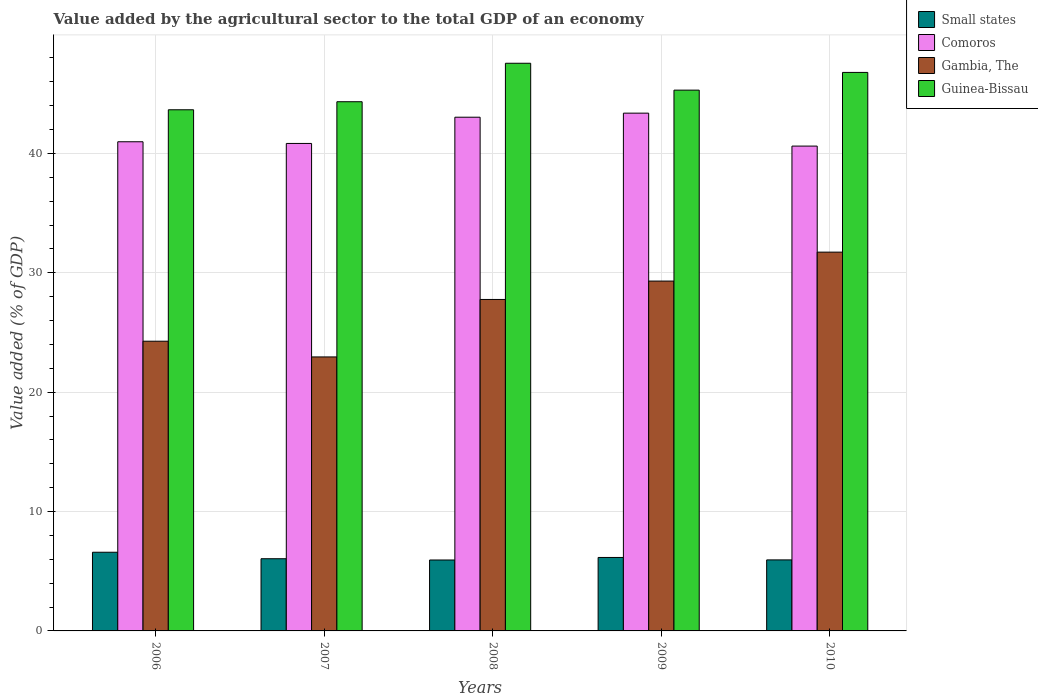How many different coloured bars are there?
Your answer should be compact. 4. How many groups of bars are there?
Give a very brief answer. 5. Are the number of bars per tick equal to the number of legend labels?
Ensure brevity in your answer.  Yes. Are the number of bars on each tick of the X-axis equal?
Provide a succinct answer. Yes. How many bars are there on the 4th tick from the right?
Provide a short and direct response. 4. In how many cases, is the number of bars for a given year not equal to the number of legend labels?
Provide a succinct answer. 0. What is the value added by the agricultural sector to the total GDP in Small states in 2008?
Your answer should be compact. 5.94. Across all years, what is the maximum value added by the agricultural sector to the total GDP in Guinea-Bissau?
Make the answer very short. 47.55. Across all years, what is the minimum value added by the agricultural sector to the total GDP in Comoros?
Your answer should be compact. 40.61. In which year was the value added by the agricultural sector to the total GDP in Small states minimum?
Your answer should be very brief. 2008. What is the total value added by the agricultural sector to the total GDP in Comoros in the graph?
Your answer should be very brief. 208.81. What is the difference between the value added by the agricultural sector to the total GDP in Gambia, The in 2007 and that in 2010?
Provide a short and direct response. -8.78. What is the difference between the value added by the agricultural sector to the total GDP in Small states in 2008 and the value added by the agricultural sector to the total GDP in Guinea-Bissau in 2006?
Ensure brevity in your answer.  -37.71. What is the average value added by the agricultural sector to the total GDP in Small states per year?
Provide a succinct answer. 6.14. In the year 2006, what is the difference between the value added by the agricultural sector to the total GDP in Guinea-Bissau and value added by the agricultural sector to the total GDP in Comoros?
Ensure brevity in your answer.  2.68. What is the ratio of the value added by the agricultural sector to the total GDP in Guinea-Bissau in 2007 to that in 2009?
Make the answer very short. 0.98. Is the value added by the agricultural sector to the total GDP in Guinea-Bissau in 2008 less than that in 2009?
Ensure brevity in your answer.  No. Is the difference between the value added by the agricultural sector to the total GDP in Guinea-Bissau in 2007 and 2008 greater than the difference between the value added by the agricultural sector to the total GDP in Comoros in 2007 and 2008?
Offer a terse response. No. What is the difference between the highest and the second highest value added by the agricultural sector to the total GDP in Small states?
Keep it short and to the point. 0.44. What is the difference between the highest and the lowest value added by the agricultural sector to the total GDP in Guinea-Bissau?
Offer a very short reply. 3.9. In how many years, is the value added by the agricultural sector to the total GDP in Guinea-Bissau greater than the average value added by the agricultural sector to the total GDP in Guinea-Bissau taken over all years?
Offer a terse response. 2. Is the sum of the value added by the agricultural sector to the total GDP in Guinea-Bissau in 2008 and 2010 greater than the maximum value added by the agricultural sector to the total GDP in Gambia, The across all years?
Give a very brief answer. Yes. Is it the case that in every year, the sum of the value added by the agricultural sector to the total GDP in Comoros and value added by the agricultural sector to the total GDP in Gambia, The is greater than the sum of value added by the agricultural sector to the total GDP in Guinea-Bissau and value added by the agricultural sector to the total GDP in Small states?
Give a very brief answer. No. What does the 3rd bar from the left in 2010 represents?
Give a very brief answer. Gambia, The. What does the 3rd bar from the right in 2009 represents?
Your answer should be compact. Comoros. How many years are there in the graph?
Make the answer very short. 5. What is the difference between two consecutive major ticks on the Y-axis?
Offer a very short reply. 10. Are the values on the major ticks of Y-axis written in scientific E-notation?
Ensure brevity in your answer.  No. Does the graph contain any zero values?
Your response must be concise. No. Does the graph contain grids?
Make the answer very short. Yes. What is the title of the graph?
Offer a terse response. Value added by the agricultural sector to the total GDP of an economy. Does "Middle East & North Africa (developing only)" appear as one of the legend labels in the graph?
Your response must be concise. No. What is the label or title of the X-axis?
Give a very brief answer. Years. What is the label or title of the Y-axis?
Ensure brevity in your answer.  Value added (% of GDP). What is the Value added (% of GDP) in Small states in 2006?
Your answer should be compact. 6.59. What is the Value added (% of GDP) of Comoros in 2006?
Your response must be concise. 40.97. What is the Value added (% of GDP) in Gambia, The in 2006?
Provide a short and direct response. 24.27. What is the Value added (% of GDP) of Guinea-Bissau in 2006?
Offer a very short reply. 43.65. What is the Value added (% of GDP) in Small states in 2007?
Provide a succinct answer. 6.05. What is the Value added (% of GDP) in Comoros in 2007?
Your answer should be very brief. 40.83. What is the Value added (% of GDP) in Gambia, The in 2007?
Keep it short and to the point. 22.95. What is the Value added (% of GDP) in Guinea-Bissau in 2007?
Give a very brief answer. 44.33. What is the Value added (% of GDP) of Small states in 2008?
Give a very brief answer. 5.94. What is the Value added (% of GDP) in Comoros in 2008?
Provide a short and direct response. 43.03. What is the Value added (% of GDP) in Gambia, The in 2008?
Offer a very short reply. 27.76. What is the Value added (% of GDP) of Guinea-Bissau in 2008?
Offer a terse response. 47.55. What is the Value added (% of GDP) in Small states in 2009?
Offer a very short reply. 6.15. What is the Value added (% of GDP) of Comoros in 2009?
Your answer should be compact. 43.37. What is the Value added (% of GDP) of Gambia, The in 2009?
Keep it short and to the point. 29.3. What is the Value added (% of GDP) of Guinea-Bissau in 2009?
Provide a short and direct response. 45.3. What is the Value added (% of GDP) of Small states in 2010?
Offer a terse response. 5.95. What is the Value added (% of GDP) of Comoros in 2010?
Your response must be concise. 40.61. What is the Value added (% of GDP) of Gambia, The in 2010?
Your answer should be very brief. 31.73. What is the Value added (% of GDP) in Guinea-Bissau in 2010?
Provide a succinct answer. 46.78. Across all years, what is the maximum Value added (% of GDP) of Small states?
Make the answer very short. 6.59. Across all years, what is the maximum Value added (% of GDP) in Comoros?
Your answer should be very brief. 43.37. Across all years, what is the maximum Value added (% of GDP) of Gambia, The?
Give a very brief answer. 31.73. Across all years, what is the maximum Value added (% of GDP) in Guinea-Bissau?
Make the answer very short. 47.55. Across all years, what is the minimum Value added (% of GDP) in Small states?
Ensure brevity in your answer.  5.94. Across all years, what is the minimum Value added (% of GDP) of Comoros?
Your answer should be compact. 40.61. Across all years, what is the minimum Value added (% of GDP) in Gambia, The?
Provide a short and direct response. 22.95. Across all years, what is the minimum Value added (% of GDP) of Guinea-Bissau?
Offer a terse response. 43.65. What is the total Value added (% of GDP) of Small states in the graph?
Ensure brevity in your answer.  30.68. What is the total Value added (% of GDP) in Comoros in the graph?
Make the answer very short. 208.81. What is the total Value added (% of GDP) in Gambia, The in the graph?
Ensure brevity in your answer.  136.01. What is the total Value added (% of GDP) of Guinea-Bissau in the graph?
Provide a short and direct response. 227.6. What is the difference between the Value added (% of GDP) in Small states in 2006 and that in 2007?
Give a very brief answer. 0.54. What is the difference between the Value added (% of GDP) in Comoros in 2006 and that in 2007?
Keep it short and to the point. 0.14. What is the difference between the Value added (% of GDP) in Gambia, The in 2006 and that in 2007?
Your answer should be very brief. 1.32. What is the difference between the Value added (% of GDP) of Guinea-Bissau in 2006 and that in 2007?
Provide a short and direct response. -0.67. What is the difference between the Value added (% of GDP) of Small states in 2006 and that in 2008?
Offer a terse response. 0.65. What is the difference between the Value added (% of GDP) in Comoros in 2006 and that in 2008?
Provide a short and direct response. -2.06. What is the difference between the Value added (% of GDP) in Gambia, The in 2006 and that in 2008?
Your answer should be compact. -3.5. What is the difference between the Value added (% of GDP) in Guinea-Bissau in 2006 and that in 2008?
Provide a short and direct response. -3.9. What is the difference between the Value added (% of GDP) in Small states in 2006 and that in 2009?
Provide a succinct answer. 0.44. What is the difference between the Value added (% of GDP) of Comoros in 2006 and that in 2009?
Your answer should be very brief. -2.4. What is the difference between the Value added (% of GDP) in Gambia, The in 2006 and that in 2009?
Make the answer very short. -5.04. What is the difference between the Value added (% of GDP) of Guinea-Bissau in 2006 and that in 2009?
Your answer should be very brief. -1.65. What is the difference between the Value added (% of GDP) of Small states in 2006 and that in 2010?
Offer a very short reply. 0.64. What is the difference between the Value added (% of GDP) of Comoros in 2006 and that in 2010?
Ensure brevity in your answer.  0.36. What is the difference between the Value added (% of GDP) of Gambia, The in 2006 and that in 2010?
Provide a short and direct response. -7.46. What is the difference between the Value added (% of GDP) in Guinea-Bissau in 2006 and that in 2010?
Give a very brief answer. -3.13. What is the difference between the Value added (% of GDP) in Small states in 2007 and that in 2008?
Offer a very short reply. 0.11. What is the difference between the Value added (% of GDP) of Comoros in 2007 and that in 2008?
Your response must be concise. -2.2. What is the difference between the Value added (% of GDP) of Gambia, The in 2007 and that in 2008?
Your answer should be very brief. -4.81. What is the difference between the Value added (% of GDP) of Guinea-Bissau in 2007 and that in 2008?
Ensure brevity in your answer.  -3.22. What is the difference between the Value added (% of GDP) of Small states in 2007 and that in 2009?
Provide a succinct answer. -0.11. What is the difference between the Value added (% of GDP) of Comoros in 2007 and that in 2009?
Offer a terse response. -2.54. What is the difference between the Value added (% of GDP) in Gambia, The in 2007 and that in 2009?
Your answer should be very brief. -6.35. What is the difference between the Value added (% of GDP) of Guinea-Bissau in 2007 and that in 2009?
Provide a short and direct response. -0.97. What is the difference between the Value added (% of GDP) of Small states in 2007 and that in 2010?
Your answer should be compact. 0.1. What is the difference between the Value added (% of GDP) in Comoros in 2007 and that in 2010?
Your answer should be compact. 0.22. What is the difference between the Value added (% of GDP) in Gambia, The in 2007 and that in 2010?
Provide a short and direct response. -8.78. What is the difference between the Value added (% of GDP) of Guinea-Bissau in 2007 and that in 2010?
Your response must be concise. -2.45. What is the difference between the Value added (% of GDP) of Small states in 2008 and that in 2009?
Give a very brief answer. -0.21. What is the difference between the Value added (% of GDP) of Comoros in 2008 and that in 2009?
Provide a short and direct response. -0.34. What is the difference between the Value added (% of GDP) in Gambia, The in 2008 and that in 2009?
Keep it short and to the point. -1.54. What is the difference between the Value added (% of GDP) of Guinea-Bissau in 2008 and that in 2009?
Provide a succinct answer. 2.25. What is the difference between the Value added (% of GDP) of Small states in 2008 and that in 2010?
Your answer should be very brief. -0.01. What is the difference between the Value added (% of GDP) in Comoros in 2008 and that in 2010?
Your response must be concise. 2.42. What is the difference between the Value added (% of GDP) in Gambia, The in 2008 and that in 2010?
Provide a succinct answer. -3.96. What is the difference between the Value added (% of GDP) in Guinea-Bissau in 2008 and that in 2010?
Ensure brevity in your answer.  0.77. What is the difference between the Value added (% of GDP) of Small states in 2009 and that in 2010?
Ensure brevity in your answer.  0.2. What is the difference between the Value added (% of GDP) in Comoros in 2009 and that in 2010?
Make the answer very short. 2.76. What is the difference between the Value added (% of GDP) of Gambia, The in 2009 and that in 2010?
Your answer should be compact. -2.42. What is the difference between the Value added (% of GDP) of Guinea-Bissau in 2009 and that in 2010?
Your response must be concise. -1.48. What is the difference between the Value added (% of GDP) in Small states in 2006 and the Value added (% of GDP) in Comoros in 2007?
Your answer should be compact. -34.24. What is the difference between the Value added (% of GDP) in Small states in 2006 and the Value added (% of GDP) in Gambia, The in 2007?
Offer a terse response. -16.36. What is the difference between the Value added (% of GDP) of Small states in 2006 and the Value added (% of GDP) of Guinea-Bissau in 2007?
Provide a succinct answer. -37.74. What is the difference between the Value added (% of GDP) in Comoros in 2006 and the Value added (% of GDP) in Gambia, The in 2007?
Your answer should be very brief. 18.02. What is the difference between the Value added (% of GDP) of Comoros in 2006 and the Value added (% of GDP) of Guinea-Bissau in 2007?
Your response must be concise. -3.35. What is the difference between the Value added (% of GDP) in Gambia, The in 2006 and the Value added (% of GDP) in Guinea-Bissau in 2007?
Provide a short and direct response. -20.06. What is the difference between the Value added (% of GDP) in Small states in 2006 and the Value added (% of GDP) in Comoros in 2008?
Your answer should be compact. -36.44. What is the difference between the Value added (% of GDP) in Small states in 2006 and the Value added (% of GDP) in Gambia, The in 2008?
Your response must be concise. -21.17. What is the difference between the Value added (% of GDP) of Small states in 2006 and the Value added (% of GDP) of Guinea-Bissau in 2008?
Make the answer very short. -40.96. What is the difference between the Value added (% of GDP) of Comoros in 2006 and the Value added (% of GDP) of Gambia, The in 2008?
Offer a very short reply. 13.21. What is the difference between the Value added (% of GDP) of Comoros in 2006 and the Value added (% of GDP) of Guinea-Bissau in 2008?
Provide a short and direct response. -6.58. What is the difference between the Value added (% of GDP) in Gambia, The in 2006 and the Value added (% of GDP) in Guinea-Bissau in 2008?
Ensure brevity in your answer.  -23.28. What is the difference between the Value added (% of GDP) in Small states in 2006 and the Value added (% of GDP) in Comoros in 2009?
Provide a short and direct response. -36.78. What is the difference between the Value added (% of GDP) in Small states in 2006 and the Value added (% of GDP) in Gambia, The in 2009?
Offer a very short reply. -22.71. What is the difference between the Value added (% of GDP) in Small states in 2006 and the Value added (% of GDP) in Guinea-Bissau in 2009?
Your answer should be very brief. -38.71. What is the difference between the Value added (% of GDP) of Comoros in 2006 and the Value added (% of GDP) of Gambia, The in 2009?
Your answer should be very brief. 11.67. What is the difference between the Value added (% of GDP) of Comoros in 2006 and the Value added (% of GDP) of Guinea-Bissau in 2009?
Make the answer very short. -4.32. What is the difference between the Value added (% of GDP) of Gambia, The in 2006 and the Value added (% of GDP) of Guinea-Bissau in 2009?
Offer a very short reply. -21.03. What is the difference between the Value added (% of GDP) of Small states in 2006 and the Value added (% of GDP) of Comoros in 2010?
Provide a short and direct response. -34.02. What is the difference between the Value added (% of GDP) of Small states in 2006 and the Value added (% of GDP) of Gambia, The in 2010?
Offer a terse response. -25.14. What is the difference between the Value added (% of GDP) in Small states in 2006 and the Value added (% of GDP) in Guinea-Bissau in 2010?
Your answer should be very brief. -40.19. What is the difference between the Value added (% of GDP) of Comoros in 2006 and the Value added (% of GDP) of Gambia, The in 2010?
Provide a short and direct response. 9.24. What is the difference between the Value added (% of GDP) in Comoros in 2006 and the Value added (% of GDP) in Guinea-Bissau in 2010?
Your response must be concise. -5.81. What is the difference between the Value added (% of GDP) in Gambia, The in 2006 and the Value added (% of GDP) in Guinea-Bissau in 2010?
Your answer should be very brief. -22.51. What is the difference between the Value added (% of GDP) of Small states in 2007 and the Value added (% of GDP) of Comoros in 2008?
Make the answer very short. -36.98. What is the difference between the Value added (% of GDP) in Small states in 2007 and the Value added (% of GDP) in Gambia, The in 2008?
Offer a terse response. -21.72. What is the difference between the Value added (% of GDP) in Small states in 2007 and the Value added (% of GDP) in Guinea-Bissau in 2008?
Give a very brief answer. -41.5. What is the difference between the Value added (% of GDP) of Comoros in 2007 and the Value added (% of GDP) of Gambia, The in 2008?
Offer a very short reply. 13.07. What is the difference between the Value added (% of GDP) of Comoros in 2007 and the Value added (% of GDP) of Guinea-Bissau in 2008?
Offer a terse response. -6.72. What is the difference between the Value added (% of GDP) of Gambia, The in 2007 and the Value added (% of GDP) of Guinea-Bissau in 2008?
Provide a short and direct response. -24.6. What is the difference between the Value added (% of GDP) in Small states in 2007 and the Value added (% of GDP) in Comoros in 2009?
Give a very brief answer. -37.32. What is the difference between the Value added (% of GDP) in Small states in 2007 and the Value added (% of GDP) in Gambia, The in 2009?
Your response must be concise. -23.26. What is the difference between the Value added (% of GDP) of Small states in 2007 and the Value added (% of GDP) of Guinea-Bissau in 2009?
Your answer should be compact. -39.25. What is the difference between the Value added (% of GDP) of Comoros in 2007 and the Value added (% of GDP) of Gambia, The in 2009?
Offer a terse response. 11.53. What is the difference between the Value added (% of GDP) in Comoros in 2007 and the Value added (% of GDP) in Guinea-Bissau in 2009?
Provide a short and direct response. -4.47. What is the difference between the Value added (% of GDP) of Gambia, The in 2007 and the Value added (% of GDP) of Guinea-Bissau in 2009?
Give a very brief answer. -22.35. What is the difference between the Value added (% of GDP) in Small states in 2007 and the Value added (% of GDP) in Comoros in 2010?
Your answer should be compact. -34.56. What is the difference between the Value added (% of GDP) of Small states in 2007 and the Value added (% of GDP) of Gambia, The in 2010?
Offer a very short reply. -25.68. What is the difference between the Value added (% of GDP) in Small states in 2007 and the Value added (% of GDP) in Guinea-Bissau in 2010?
Your response must be concise. -40.73. What is the difference between the Value added (% of GDP) in Comoros in 2007 and the Value added (% of GDP) in Gambia, The in 2010?
Your answer should be very brief. 9.1. What is the difference between the Value added (% of GDP) in Comoros in 2007 and the Value added (% of GDP) in Guinea-Bissau in 2010?
Give a very brief answer. -5.95. What is the difference between the Value added (% of GDP) of Gambia, The in 2007 and the Value added (% of GDP) of Guinea-Bissau in 2010?
Provide a succinct answer. -23.83. What is the difference between the Value added (% of GDP) in Small states in 2008 and the Value added (% of GDP) in Comoros in 2009?
Keep it short and to the point. -37.43. What is the difference between the Value added (% of GDP) in Small states in 2008 and the Value added (% of GDP) in Gambia, The in 2009?
Keep it short and to the point. -23.36. What is the difference between the Value added (% of GDP) of Small states in 2008 and the Value added (% of GDP) of Guinea-Bissau in 2009?
Your answer should be compact. -39.36. What is the difference between the Value added (% of GDP) of Comoros in 2008 and the Value added (% of GDP) of Gambia, The in 2009?
Give a very brief answer. 13.72. What is the difference between the Value added (% of GDP) of Comoros in 2008 and the Value added (% of GDP) of Guinea-Bissau in 2009?
Provide a short and direct response. -2.27. What is the difference between the Value added (% of GDP) of Gambia, The in 2008 and the Value added (% of GDP) of Guinea-Bissau in 2009?
Your answer should be very brief. -17.53. What is the difference between the Value added (% of GDP) of Small states in 2008 and the Value added (% of GDP) of Comoros in 2010?
Give a very brief answer. -34.67. What is the difference between the Value added (% of GDP) in Small states in 2008 and the Value added (% of GDP) in Gambia, The in 2010?
Provide a succinct answer. -25.79. What is the difference between the Value added (% of GDP) of Small states in 2008 and the Value added (% of GDP) of Guinea-Bissau in 2010?
Provide a succinct answer. -40.84. What is the difference between the Value added (% of GDP) of Comoros in 2008 and the Value added (% of GDP) of Gambia, The in 2010?
Provide a short and direct response. 11.3. What is the difference between the Value added (% of GDP) in Comoros in 2008 and the Value added (% of GDP) in Guinea-Bissau in 2010?
Give a very brief answer. -3.75. What is the difference between the Value added (% of GDP) of Gambia, The in 2008 and the Value added (% of GDP) of Guinea-Bissau in 2010?
Your response must be concise. -19.02. What is the difference between the Value added (% of GDP) in Small states in 2009 and the Value added (% of GDP) in Comoros in 2010?
Offer a very short reply. -34.46. What is the difference between the Value added (% of GDP) in Small states in 2009 and the Value added (% of GDP) in Gambia, The in 2010?
Provide a short and direct response. -25.57. What is the difference between the Value added (% of GDP) of Small states in 2009 and the Value added (% of GDP) of Guinea-Bissau in 2010?
Keep it short and to the point. -40.63. What is the difference between the Value added (% of GDP) of Comoros in 2009 and the Value added (% of GDP) of Gambia, The in 2010?
Your response must be concise. 11.64. What is the difference between the Value added (% of GDP) of Comoros in 2009 and the Value added (% of GDP) of Guinea-Bissau in 2010?
Your answer should be compact. -3.41. What is the difference between the Value added (% of GDP) of Gambia, The in 2009 and the Value added (% of GDP) of Guinea-Bissau in 2010?
Ensure brevity in your answer.  -17.48. What is the average Value added (% of GDP) in Small states per year?
Give a very brief answer. 6.14. What is the average Value added (% of GDP) of Comoros per year?
Offer a terse response. 41.76. What is the average Value added (% of GDP) in Gambia, The per year?
Offer a terse response. 27.2. What is the average Value added (% of GDP) in Guinea-Bissau per year?
Provide a short and direct response. 45.52. In the year 2006, what is the difference between the Value added (% of GDP) in Small states and Value added (% of GDP) in Comoros?
Ensure brevity in your answer.  -34.38. In the year 2006, what is the difference between the Value added (% of GDP) in Small states and Value added (% of GDP) in Gambia, The?
Provide a short and direct response. -17.68. In the year 2006, what is the difference between the Value added (% of GDP) of Small states and Value added (% of GDP) of Guinea-Bissau?
Keep it short and to the point. -37.06. In the year 2006, what is the difference between the Value added (% of GDP) in Comoros and Value added (% of GDP) in Gambia, The?
Give a very brief answer. 16.71. In the year 2006, what is the difference between the Value added (% of GDP) of Comoros and Value added (% of GDP) of Guinea-Bissau?
Offer a terse response. -2.68. In the year 2006, what is the difference between the Value added (% of GDP) in Gambia, The and Value added (% of GDP) in Guinea-Bissau?
Provide a short and direct response. -19.39. In the year 2007, what is the difference between the Value added (% of GDP) of Small states and Value added (% of GDP) of Comoros?
Keep it short and to the point. -34.78. In the year 2007, what is the difference between the Value added (% of GDP) of Small states and Value added (% of GDP) of Gambia, The?
Your answer should be very brief. -16.9. In the year 2007, what is the difference between the Value added (% of GDP) in Small states and Value added (% of GDP) in Guinea-Bissau?
Your answer should be compact. -38.28. In the year 2007, what is the difference between the Value added (% of GDP) of Comoros and Value added (% of GDP) of Gambia, The?
Make the answer very short. 17.88. In the year 2007, what is the difference between the Value added (% of GDP) of Comoros and Value added (% of GDP) of Guinea-Bissau?
Offer a very short reply. -3.49. In the year 2007, what is the difference between the Value added (% of GDP) of Gambia, The and Value added (% of GDP) of Guinea-Bissau?
Give a very brief answer. -21.38. In the year 2008, what is the difference between the Value added (% of GDP) of Small states and Value added (% of GDP) of Comoros?
Your answer should be very brief. -37.09. In the year 2008, what is the difference between the Value added (% of GDP) in Small states and Value added (% of GDP) in Gambia, The?
Your answer should be compact. -21.82. In the year 2008, what is the difference between the Value added (% of GDP) of Small states and Value added (% of GDP) of Guinea-Bissau?
Make the answer very short. -41.61. In the year 2008, what is the difference between the Value added (% of GDP) of Comoros and Value added (% of GDP) of Gambia, The?
Offer a terse response. 15.27. In the year 2008, what is the difference between the Value added (% of GDP) in Comoros and Value added (% of GDP) in Guinea-Bissau?
Make the answer very short. -4.52. In the year 2008, what is the difference between the Value added (% of GDP) in Gambia, The and Value added (% of GDP) in Guinea-Bissau?
Ensure brevity in your answer.  -19.78. In the year 2009, what is the difference between the Value added (% of GDP) in Small states and Value added (% of GDP) in Comoros?
Keep it short and to the point. -37.22. In the year 2009, what is the difference between the Value added (% of GDP) in Small states and Value added (% of GDP) in Gambia, The?
Make the answer very short. -23.15. In the year 2009, what is the difference between the Value added (% of GDP) of Small states and Value added (% of GDP) of Guinea-Bissau?
Your response must be concise. -39.14. In the year 2009, what is the difference between the Value added (% of GDP) in Comoros and Value added (% of GDP) in Gambia, The?
Offer a very short reply. 14.06. In the year 2009, what is the difference between the Value added (% of GDP) in Comoros and Value added (% of GDP) in Guinea-Bissau?
Offer a very short reply. -1.93. In the year 2009, what is the difference between the Value added (% of GDP) in Gambia, The and Value added (% of GDP) in Guinea-Bissau?
Give a very brief answer. -15.99. In the year 2010, what is the difference between the Value added (% of GDP) in Small states and Value added (% of GDP) in Comoros?
Make the answer very short. -34.66. In the year 2010, what is the difference between the Value added (% of GDP) of Small states and Value added (% of GDP) of Gambia, The?
Give a very brief answer. -25.78. In the year 2010, what is the difference between the Value added (% of GDP) in Small states and Value added (% of GDP) in Guinea-Bissau?
Provide a short and direct response. -40.83. In the year 2010, what is the difference between the Value added (% of GDP) in Comoros and Value added (% of GDP) in Gambia, The?
Provide a short and direct response. 8.88. In the year 2010, what is the difference between the Value added (% of GDP) in Comoros and Value added (% of GDP) in Guinea-Bissau?
Give a very brief answer. -6.17. In the year 2010, what is the difference between the Value added (% of GDP) of Gambia, The and Value added (% of GDP) of Guinea-Bissau?
Provide a short and direct response. -15.05. What is the ratio of the Value added (% of GDP) of Small states in 2006 to that in 2007?
Provide a short and direct response. 1.09. What is the ratio of the Value added (% of GDP) of Gambia, The in 2006 to that in 2007?
Provide a short and direct response. 1.06. What is the ratio of the Value added (% of GDP) in Guinea-Bissau in 2006 to that in 2007?
Your answer should be compact. 0.98. What is the ratio of the Value added (% of GDP) of Small states in 2006 to that in 2008?
Your answer should be compact. 1.11. What is the ratio of the Value added (% of GDP) in Comoros in 2006 to that in 2008?
Provide a succinct answer. 0.95. What is the ratio of the Value added (% of GDP) in Gambia, The in 2006 to that in 2008?
Give a very brief answer. 0.87. What is the ratio of the Value added (% of GDP) of Guinea-Bissau in 2006 to that in 2008?
Your answer should be compact. 0.92. What is the ratio of the Value added (% of GDP) in Small states in 2006 to that in 2009?
Keep it short and to the point. 1.07. What is the ratio of the Value added (% of GDP) of Comoros in 2006 to that in 2009?
Offer a very short reply. 0.94. What is the ratio of the Value added (% of GDP) of Gambia, The in 2006 to that in 2009?
Ensure brevity in your answer.  0.83. What is the ratio of the Value added (% of GDP) of Guinea-Bissau in 2006 to that in 2009?
Your answer should be very brief. 0.96. What is the ratio of the Value added (% of GDP) in Small states in 2006 to that in 2010?
Provide a short and direct response. 1.11. What is the ratio of the Value added (% of GDP) of Comoros in 2006 to that in 2010?
Offer a terse response. 1.01. What is the ratio of the Value added (% of GDP) of Gambia, The in 2006 to that in 2010?
Give a very brief answer. 0.76. What is the ratio of the Value added (% of GDP) in Guinea-Bissau in 2006 to that in 2010?
Provide a succinct answer. 0.93. What is the ratio of the Value added (% of GDP) of Small states in 2007 to that in 2008?
Keep it short and to the point. 1.02. What is the ratio of the Value added (% of GDP) in Comoros in 2007 to that in 2008?
Make the answer very short. 0.95. What is the ratio of the Value added (% of GDP) in Gambia, The in 2007 to that in 2008?
Make the answer very short. 0.83. What is the ratio of the Value added (% of GDP) of Guinea-Bissau in 2007 to that in 2008?
Your response must be concise. 0.93. What is the ratio of the Value added (% of GDP) of Small states in 2007 to that in 2009?
Offer a terse response. 0.98. What is the ratio of the Value added (% of GDP) in Comoros in 2007 to that in 2009?
Provide a short and direct response. 0.94. What is the ratio of the Value added (% of GDP) of Gambia, The in 2007 to that in 2009?
Give a very brief answer. 0.78. What is the ratio of the Value added (% of GDP) of Guinea-Bissau in 2007 to that in 2009?
Your response must be concise. 0.98. What is the ratio of the Value added (% of GDP) of Small states in 2007 to that in 2010?
Your answer should be very brief. 1.02. What is the ratio of the Value added (% of GDP) of Comoros in 2007 to that in 2010?
Make the answer very short. 1.01. What is the ratio of the Value added (% of GDP) in Gambia, The in 2007 to that in 2010?
Provide a succinct answer. 0.72. What is the ratio of the Value added (% of GDP) in Guinea-Bissau in 2007 to that in 2010?
Your answer should be compact. 0.95. What is the ratio of the Value added (% of GDP) in Small states in 2008 to that in 2009?
Make the answer very short. 0.97. What is the ratio of the Value added (% of GDP) of Guinea-Bissau in 2008 to that in 2009?
Offer a very short reply. 1.05. What is the ratio of the Value added (% of GDP) of Comoros in 2008 to that in 2010?
Offer a very short reply. 1.06. What is the ratio of the Value added (% of GDP) in Gambia, The in 2008 to that in 2010?
Your answer should be compact. 0.88. What is the ratio of the Value added (% of GDP) in Guinea-Bissau in 2008 to that in 2010?
Your answer should be compact. 1.02. What is the ratio of the Value added (% of GDP) of Small states in 2009 to that in 2010?
Offer a very short reply. 1.03. What is the ratio of the Value added (% of GDP) of Comoros in 2009 to that in 2010?
Provide a succinct answer. 1.07. What is the ratio of the Value added (% of GDP) of Gambia, The in 2009 to that in 2010?
Your answer should be very brief. 0.92. What is the ratio of the Value added (% of GDP) of Guinea-Bissau in 2009 to that in 2010?
Offer a very short reply. 0.97. What is the difference between the highest and the second highest Value added (% of GDP) of Small states?
Provide a short and direct response. 0.44. What is the difference between the highest and the second highest Value added (% of GDP) of Comoros?
Offer a very short reply. 0.34. What is the difference between the highest and the second highest Value added (% of GDP) in Gambia, The?
Offer a terse response. 2.42. What is the difference between the highest and the second highest Value added (% of GDP) of Guinea-Bissau?
Offer a very short reply. 0.77. What is the difference between the highest and the lowest Value added (% of GDP) of Small states?
Your answer should be compact. 0.65. What is the difference between the highest and the lowest Value added (% of GDP) of Comoros?
Your response must be concise. 2.76. What is the difference between the highest and the lowest Value added (% of GDP) in Gambia, The?
Offer a terse response. 8.78. What is the difference between the highest and the lowest Value added (% of GDP) of Guinea-Bissau?
Offer a very short reply. 3.9. 